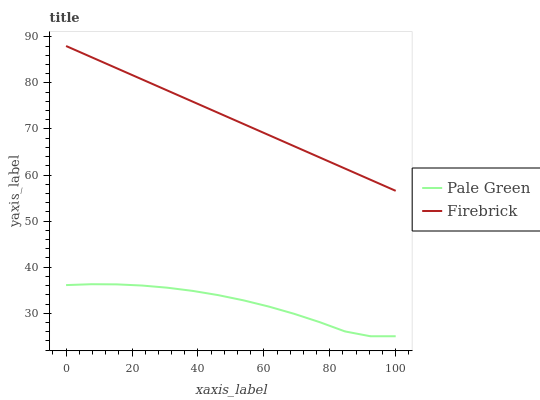Does Pale Green have the minimum area under the curve?
Answer yes or no. Yes. Does Firebrick have the maximum area under the curve?
Answer yes or no. Yes. Does Pale Green have the maximum area under the curve?
Answer yes or no. No. Is Firebrick the smoothest?
Answer yes or no. Yes. Is Pale Green the roughest?
Answer yes or no. Yes. Is Pale Green the smoothest?
Answer yes or no. No. Does Pale Green have the lowest value?
Answer yes or no. Yes. Does Firebrick have the highest value?
Answer yes or no. Yes. Does Pale Green have the highest value?
Answer yes or no. No. Is Pale Green less than Firebrick?
Answer yes or no. Yes. Is Firebrick greater than Pale Green?
Answer yes or no. Yes. Does Pale Green intersect Firebrick?
Answer yes or no. No. 